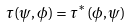Convert formula to latex. <formula><loc_0><loc_0><loc_500><loc_500>\tau ( \psi , \phi ) = \tau ^ { * } ( \phi , \psi )</formula> 